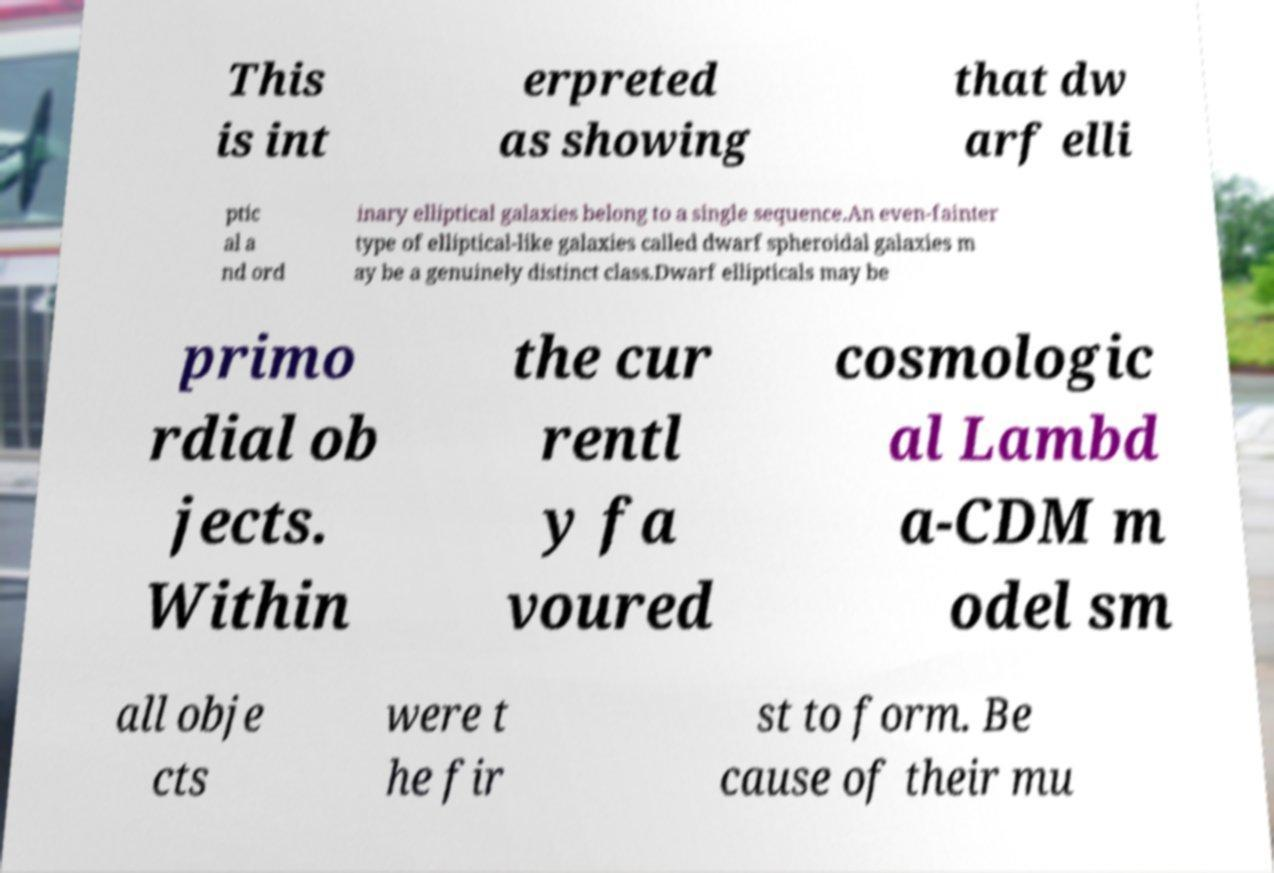There's text embedded in this image that I need extracted. Can you transcribe it verbatim? This is int erpreted as showing that dw arf elli ptic al a nd ord inary elliptical galaxies belong to a single sequence.An even-fainter type of elliptical-like galaxies called dwarf spheroidal galaxies m ay be a genuinely distinct class.Dwarf ellipticals may be primo rdial ob jects. Within the cur rentl y fa voured cosmologic al Lambd a-CDM m odel sm all obje cts were t he fir st to form. Be cause of their mu 